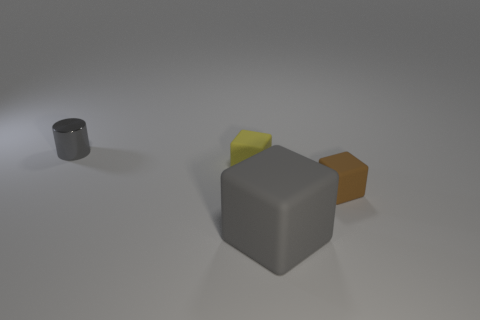Add 1 tiny brown blocks. How many objects exist? 5 Subtract all blocks. How many objects are left? 1 Subtract 0 yellow cylinders. How many objects are left? 4 Subtract all tiny cyan rubber spheres. Subtract all matte cubes. How many objects are left? 1 Add 3 small rubber things. How many small rubber things are left? 5 Add 1 large green matte balls. How many large green matte balls exist? 1 